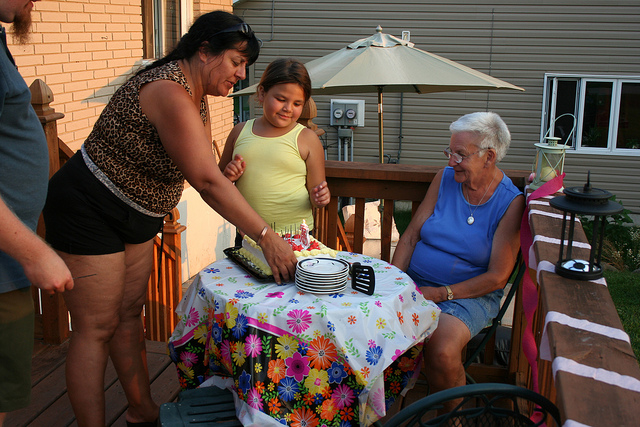<image>Do obese kids grow up to be average weight? It's ambiguous whether obese kids will grow up to be of average weight or not. It can depend on various factors. Do obese kids grow up to be average weight? It is not clear if obese kids grow up to be average weight. It can be both yes and no. 